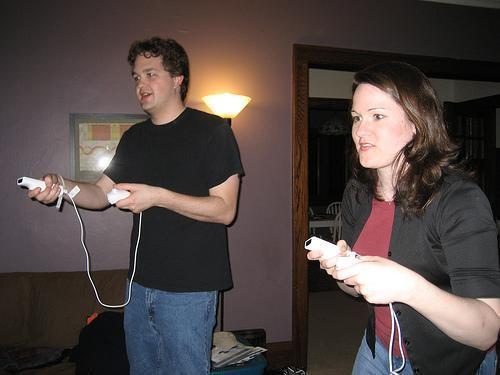How many people are in the photo?
Give a very brief answer. 2. How many hands are holding something?
Give a very brief answer. 4. How many lights are visible?
Give a very brief answer. 1. 